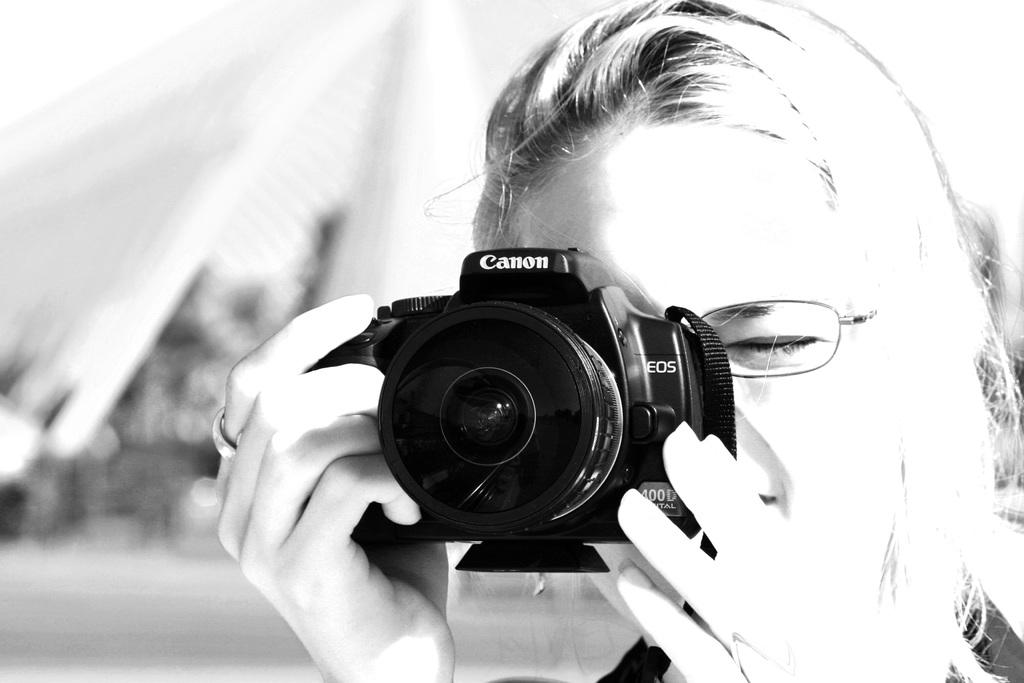What is the main subject of the image? The main subject of the image is a woman. What is the woman holding in the image? The woman is holding a camera. How many chairs can be seen in the image? There are no chairs present in the image. What type of paper is the woman using to write her thoughts in the image? There is no paper visible in the image, as the woman is holding a camera. 